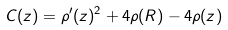Convert formula to latex. <formula><loc_0><loc_0><loc_500><loc_500>C ( z ) = \rho ^ { \prime } ( z ) ^ { 2 } + 4 \rho ( R ) - 4 \rho ( z )</formula> 